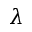Convert formula to latex. <formula><loc_0><loc_0><loc_500><loc_500>\lambda</formula> 